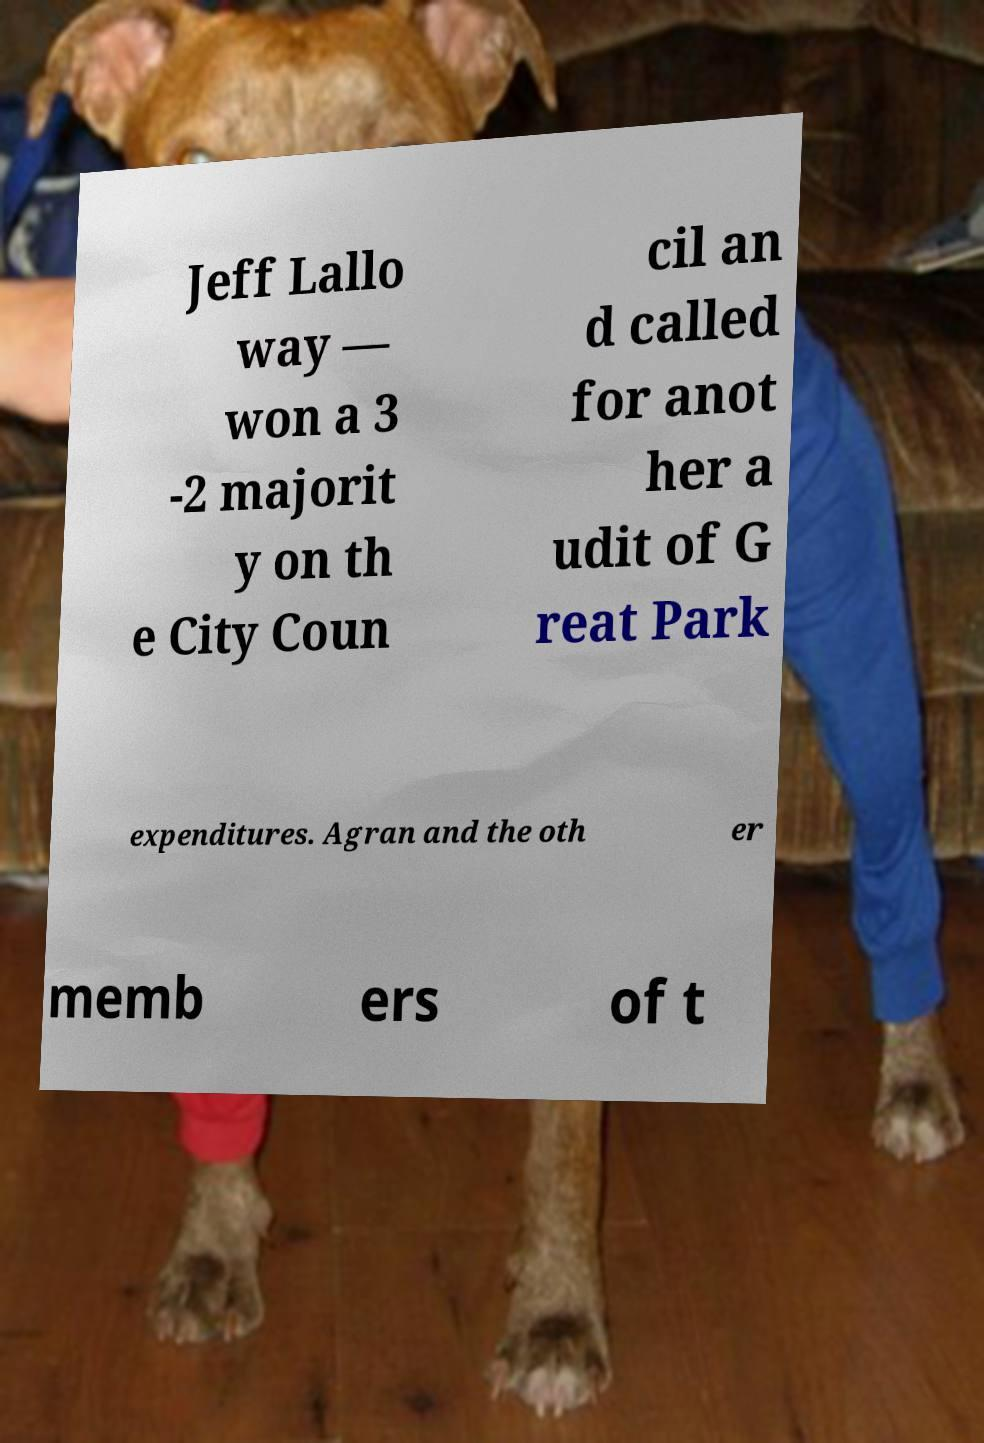For documentation purposes, I need the text within this image transcribed. Could you provide that? Jeff Lallo way — won a 3 -2 majorit y on th e City Coun cil an d called for anot her a udit of G reat Park expenditures. Agran and the oth er memb ers of t 